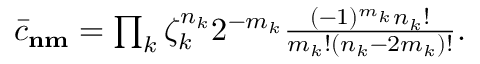<formula> <loc_0><loc_0><loc_500><loc_500>\begin{array} { r } { \bar { c } _ { n m } = \prod _ { k } \zeta _ { k } ^ { n _ { k } } 2 ^ { - m _ { k } } \frac { ( - 1 ) ^ { m _ { k } } n _ { k } ! } { m _ { k } ! ( n _ { k } - 2 m _ { k } ) ! } . } \end{array}</formula> 